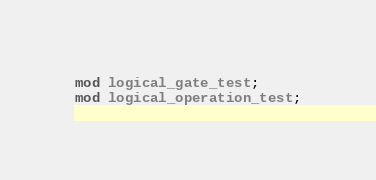Convert code to text. <code><loc_0><loc_0><loc_500><loc_500><_Rust_>mod logical_gate_test;
mod logical_operation_test;
</code> 